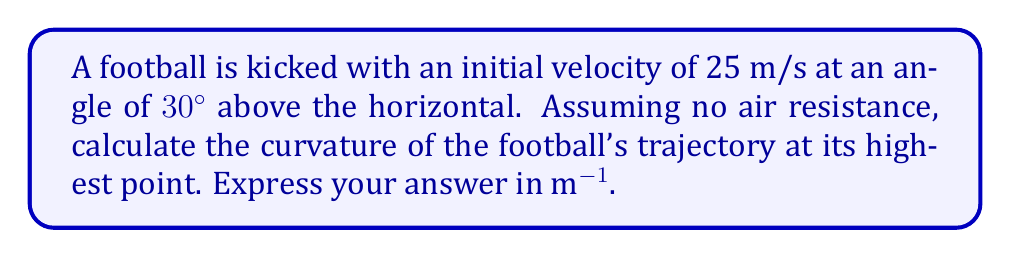Could you help me with this problem? Let's approach this step-by-step:

1) The trajectory of a projectile (like a football) under gravity with no air resistance is a parabola. We can describe this path using parametric equations:

   $$x(t) = v_0 \cos(\theta) t$$
   $$y(t) = v_0 \sin(\theta) t - \frac{1}{2}gt^2$$

   Where $v_0$ is the initial velocity, $\theta$ is the launch angle, and $g$ is the acceleration due to gravity (9.8 m/s^2).

2) The curvature $\kappa$ of a parametric curve is given by:

   $$\kappa = \frac{|\dot{x}\ddot{y} - \dot{y}\ddot{x}|}{(\dot{x}^2 + \dot{y}^2)^{3/2}}$$

3) Let's calculate the derivatives:
   
   $$\dot{x} = v_0 \cos(\theta)$$
   $$\ddot{x} = 0$$
   $$\dot{y} = v_0 \sin(\theta) - gt$$
   $$\ddot{y} = -g$$

4) The highest point occurs when $\dot{y} = 0$, i.e., when:

   $$v_0 \sin(\theta) - gt = 0$$
   $$t = \frac{v_0 \sin(\theta)}{g}$$

5) Substituting the given values ($v_0 = 25$ m/s, $\theta = 30°$):

   $$t = \frac{25 \sin(30°)}{9.8} \approx 1.27 \text{ s}$$

6) Now, let's substitute all these into our curvature formula:

   $$\kappa = \frac{|v_0 \cos(\theta) \cdot (-g) - 0 \cdot (v_0 \sin(\theta) - gt)|}{((v_0 \cos(\theta))^2 + (v_0 \sin(\theta) - gt)^2)^{3/2}}$$

7) At the highest point, $v_0 \sin(\theta) - gt = 0$, so this simplifies to:

   $$\kappa = \frac{g}{(v_0 \cos(\theta))^2}$$

8) Finally, substituting the values:

   $$\kappa = \frac{9.8}{(25 \cos(30°))^2} \approx 0.0196 \text{ m}^{-1}$$
Answer: 0.0196 m^(-1) 